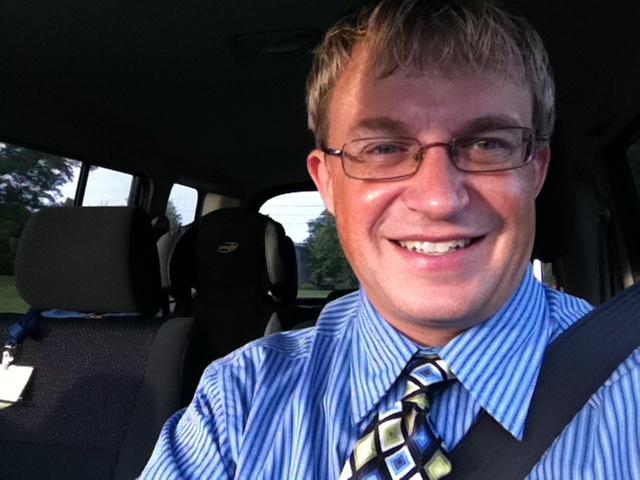Describe the objects in this image and their specific colors. I can see people in black, brown, and lightblue tones and tie in black, white, navy, and gray tones in this image. 